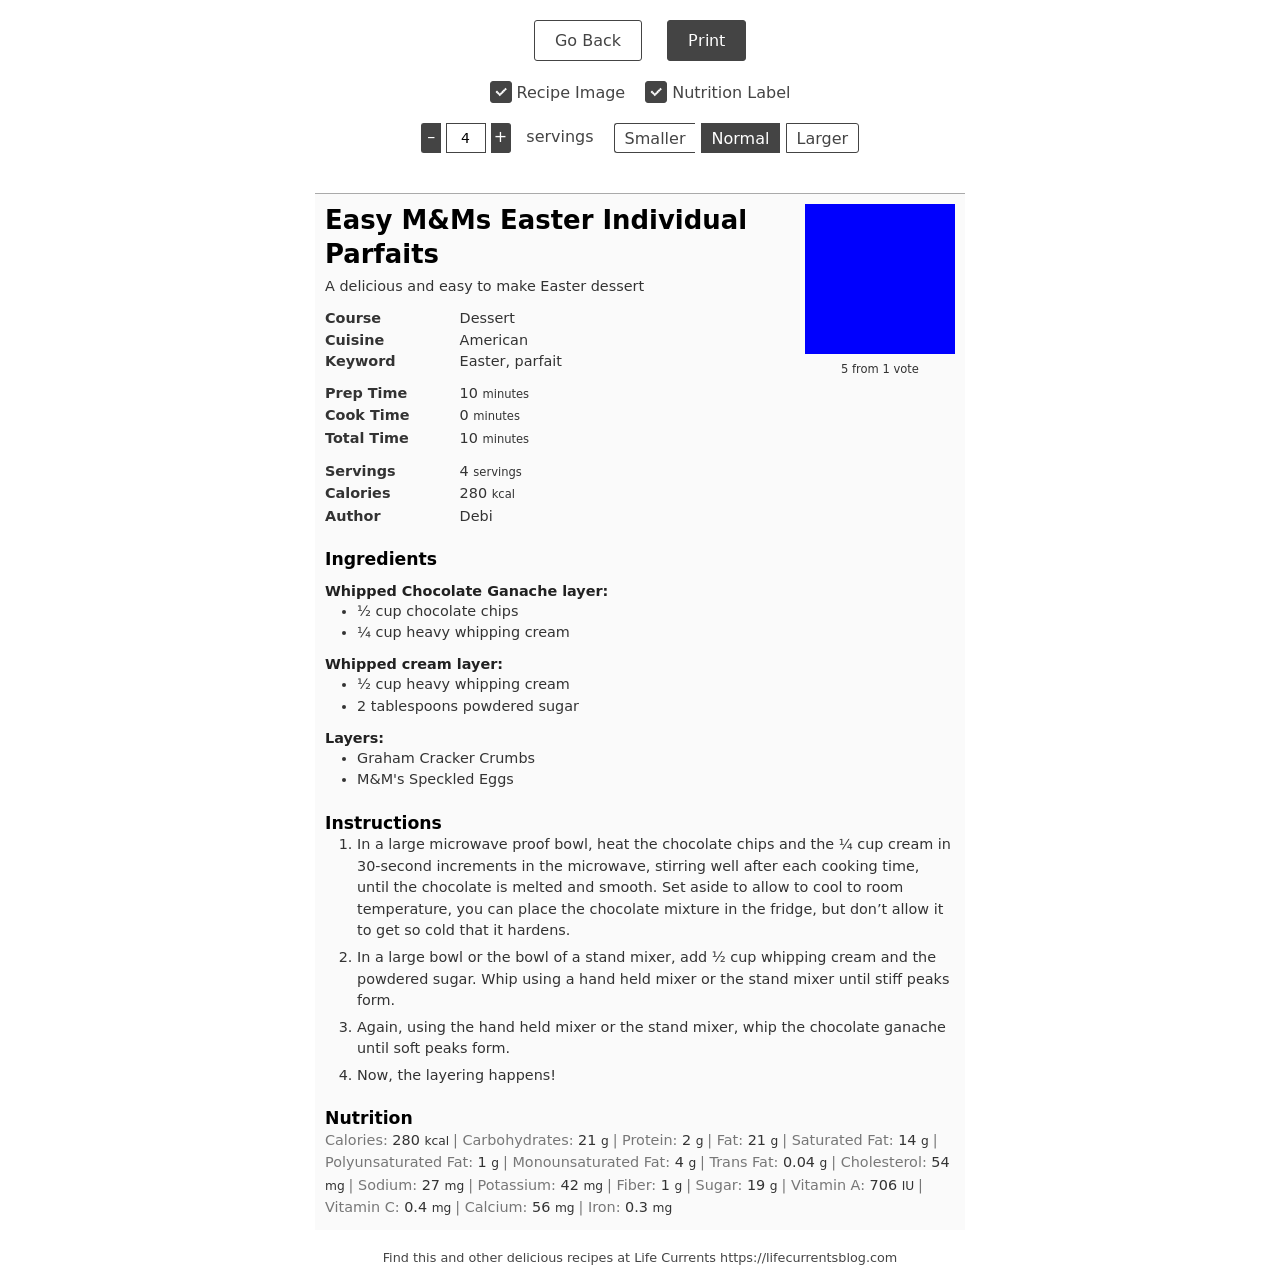How long does it typically take to prepare this dessert? This dessert is quite quick and easy to prepare, typically taking about 10 minutes of prep time. There's no cooking involved, only assembling, so it's a great last-minute treat for any occasion. 